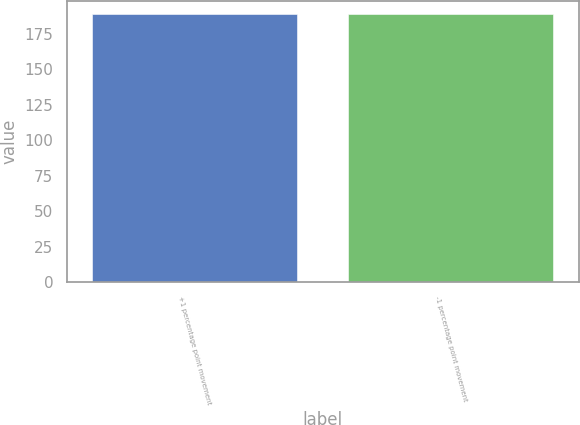<chart> <loc_0><loc_0><loc_500><loc_500><bar_chart><fcel>+1 percentage point movement<fcel>-1 percentage point movement<nl><fcel>189<fcel>189.1<nl></chart> 